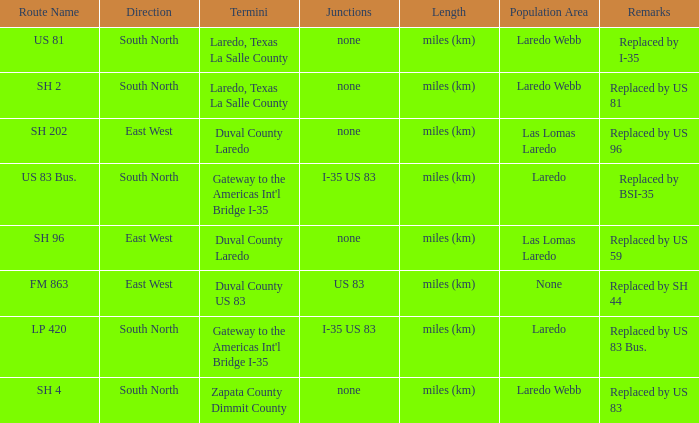What unit of length is being used for the route with "replaced by us 81" in their remarks section? Miles (km). 